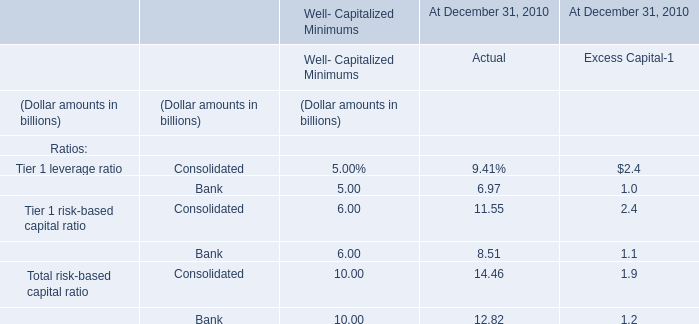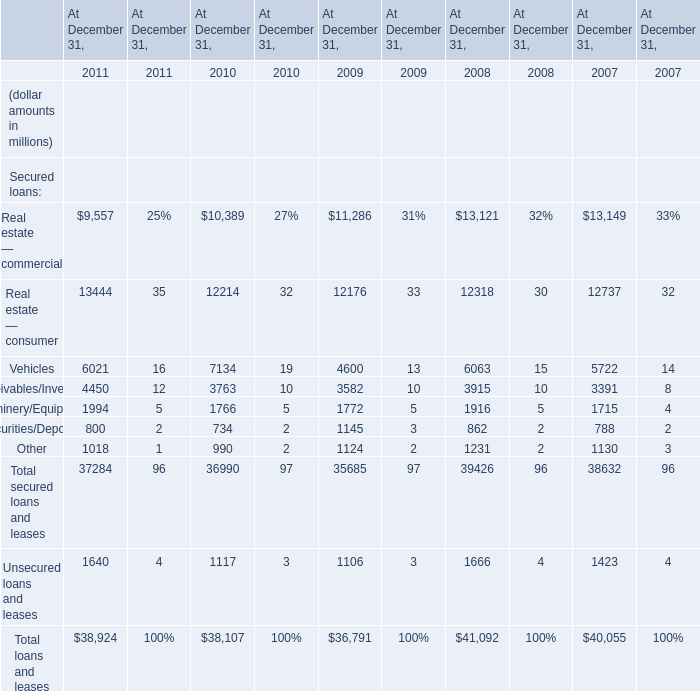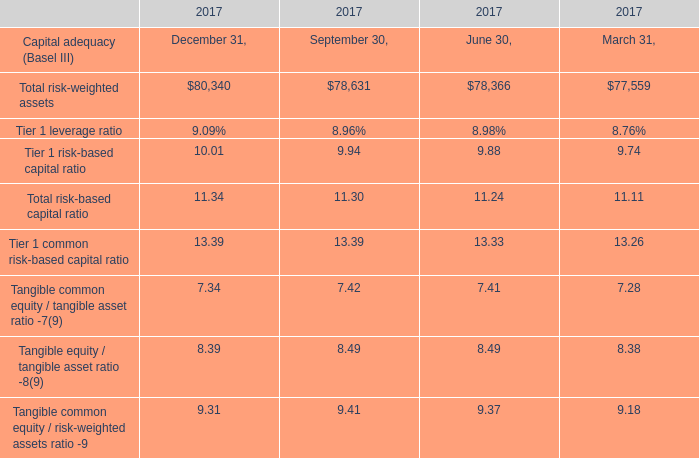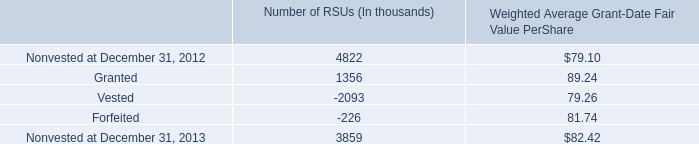What is the average value of Other in 2010, 2009, and 2008? (in million) 
Computations: (((990 + 1124) + 1231) / 3)
Answer: 1115.0. 